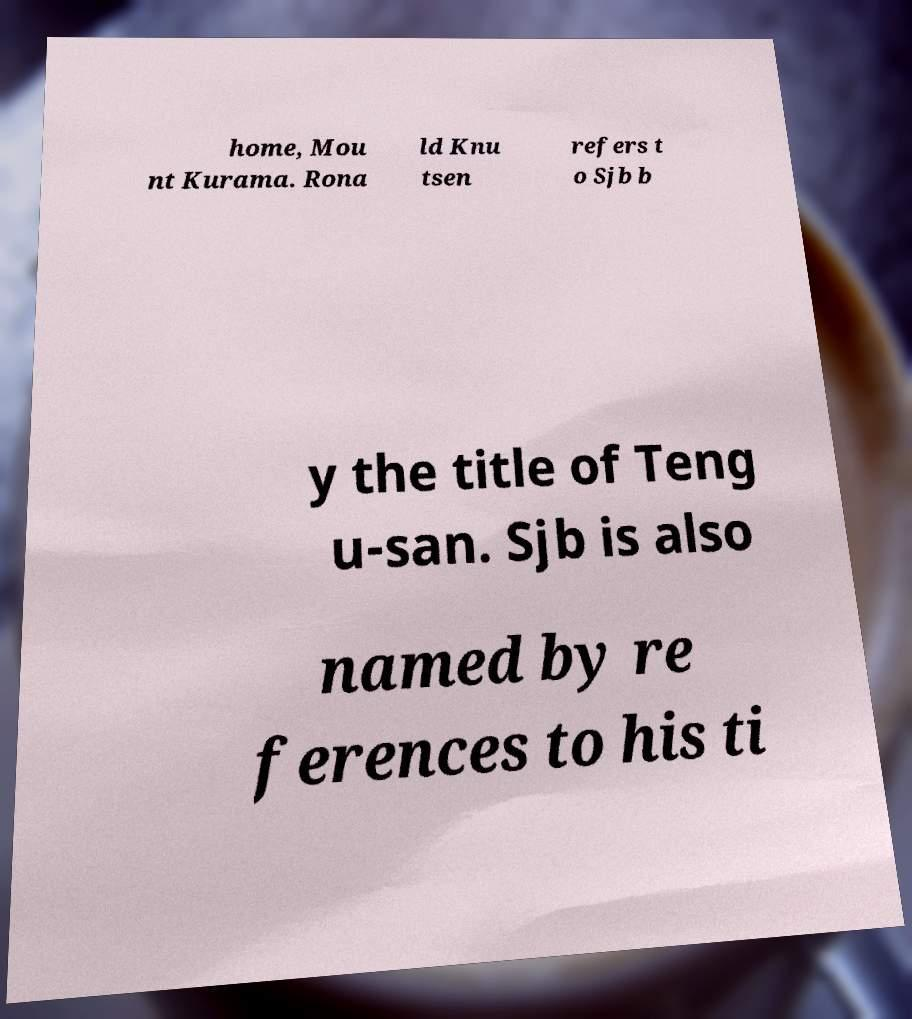Can you accurately transcribe the text from the provided image for me? home, Mou nt Kurama. Rona ld Knu tsen refers t o Sjb b y the title of Teng u-san. Sjb is also named by re ferences to his ti 